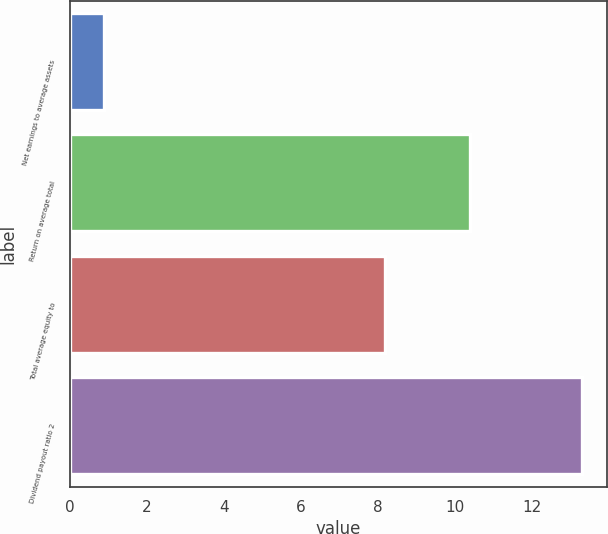Convert chart. <chart><loc_0><loc_0><loc_500><loc_500><bar_chart><fcel>Net earnings to average assets<fcel>Return on average total<fcel>Total average equity to<fcel>Dividend payout ratio 2<nl><fcel>0.9<fcel>10.4<fcel>8.2<fcel>13.3<nl></chart> 